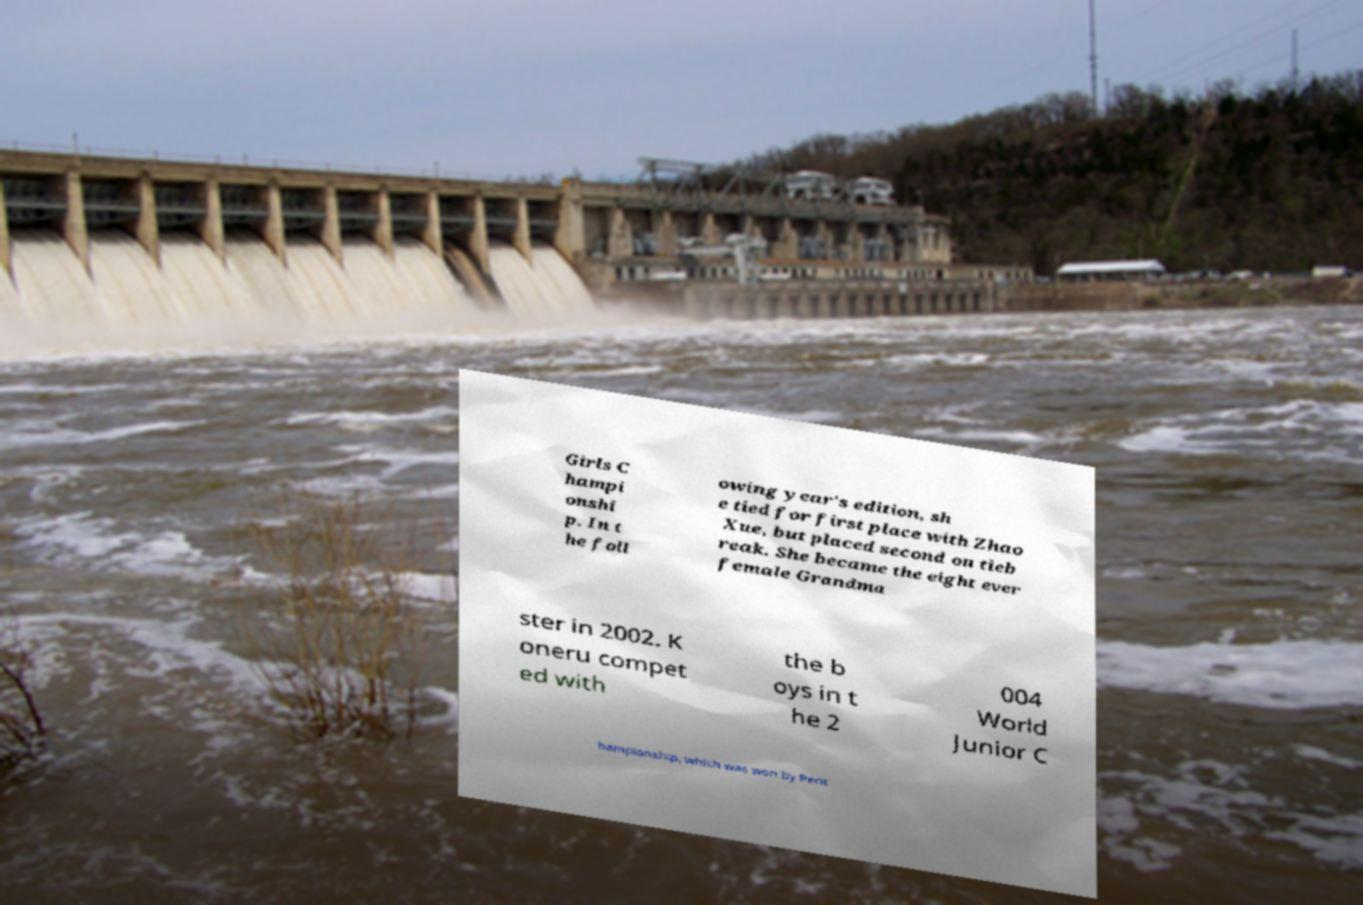Can you accurately transcribe the text from the provided image for me? Girls C hampi onshi p. In t he foll owing year's edition, sh e tied for first place with Zhao Xue, but placed second on tieb reak. She became the eight ever female Grandma ster in 2002. K oneru compet ed with the b oys in t he 2 004 World Junior C hampionship, which was won by Pent 